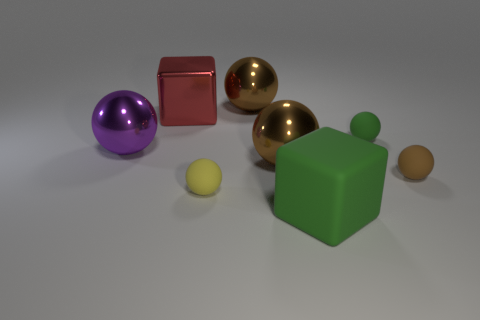What shape is the tiny rubber thing that is the same color as the large rubber thing?
Provide a short and direct response. Sphere. What number of objects are either tiny matte spheres that are on the right side of the yellow sphere or cubes that are in front of the large purple thing?
Offer a terse response. 3. Does the purple sphere have the same material as the big brown ball that is in front of the red metallic cube?
Your response must be concise. Yes. What number of other things are the same shape as the purple metallic object?
Keep it short and to the point. 5. There is a block that is behind the large cube that is to the right of the tiny rubber sphere that is in front of the small brown matte thing; what is it made of?
Give a very brief answer. Metal. Are there the same number of brown metallic spheres that are behind the tiny green object and gray shiny balls?
Your response must be concise. No. Are the green object behind the big green rubber object and the tiny yellow object that is in front of the red block made of the same material?
Provide a short and direct response. Yes. Are there any other things that have the same material as the large purple thing?
Ensure brevity in your answer.  Yes. There is a green object behind the yellow rubber sphere; is it the same shape as the large purple metal object that is left of the yellow matte sphere?
Keep it short and to the point. Yes. Are there fewer big purple metallic things right of the yellow rubber sphere than big yellow balls?
Your answer should be compact. No. 